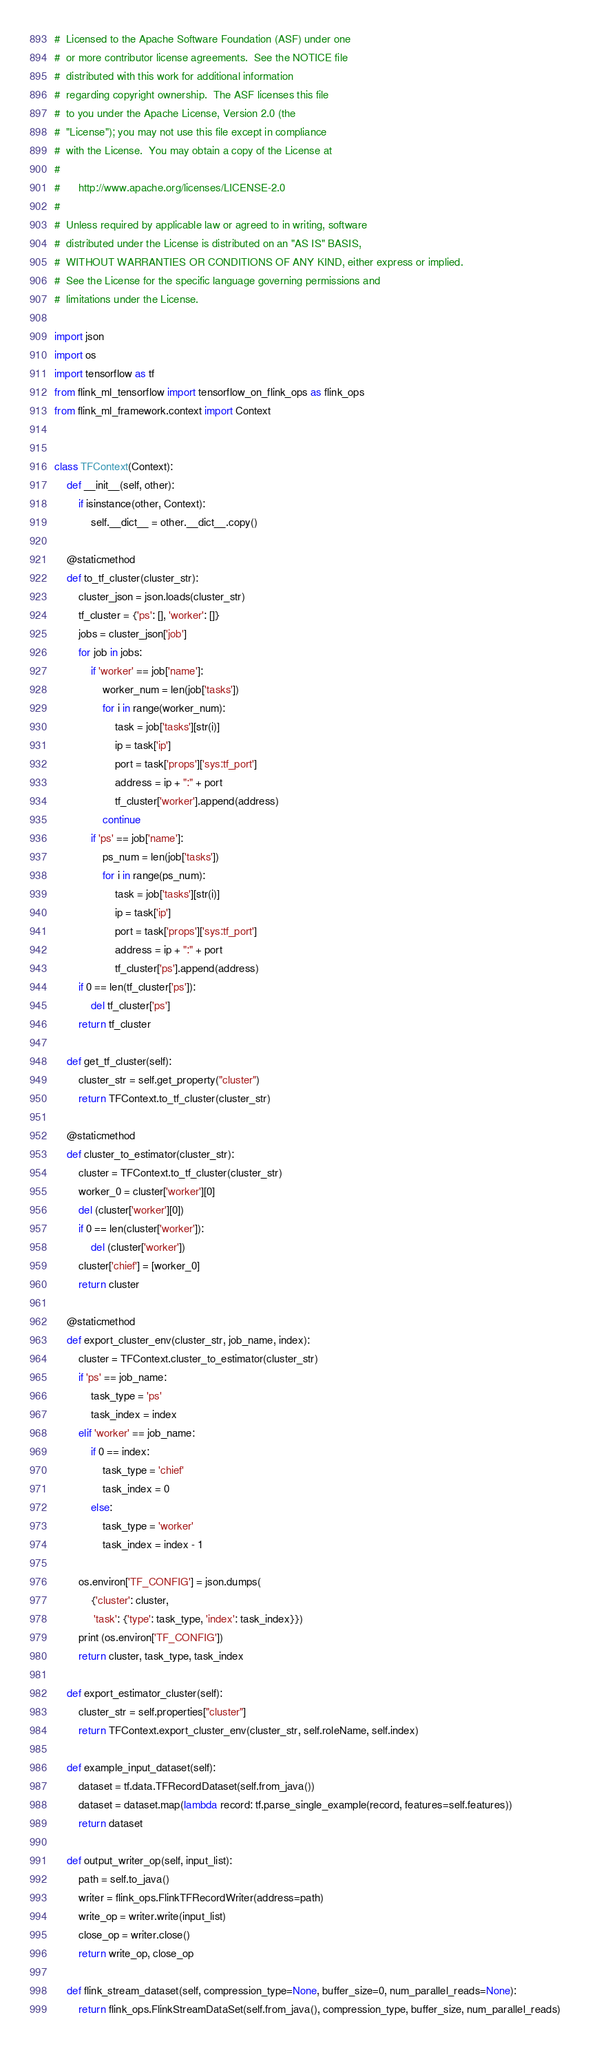<code> <loc_0><loc_0><loc_500><loc_500><_Python_>#  Licensed to the Apache Software Foundation (ASF) under one
#  or more contributor license agreements.  See the NOTICE file
#  distributed with this work for additional information
#  regarding copyright ownership.  The ASF licenses this file
#  to you under the Apache License, Version 2.0 (the
#  "License"); you may not use this file except in compliance
#  with the License.  You may obtain a copy of the License at
#
#      http://www.apache.org/licenses/LICENSE-2.0
#
#  Unless required by applicable law or agreed to in writing, software
#  distributed under the License is distributed on an "AS IS" BASIS,
#  WITHOUT WARRANTIES OR CONDITIONS OF ANY KIND, either express or implied.
#  See the License for the specific language governing permissions and
#  limitations under the License.

import json
import os
import tensorflow as tf
from flink_ml_tensorflow import tensorflow_on_flink_ops as flink_ops
from flink_ml_framework.context import Context


class TFContext(Context):
    def __init__(self, other):
        if isinstance(other, Context):
            self.__dict__ = other.__dict__.copy()

    @staticmethod
    def to_tf_cluster(cluster_str):
        cluster_json = json.loads(cluster_str)
        tf_cluster = {'ps': [], 'worker': []}
        jobs = cluster_json['job']
        for job in jobs:
            if 'worker' == job['name']:
                worker_num = len(job['tasks'])
                for i in range(worker_num):
                    task = job['tasks'][str(i)]
                    ip = task['ip']
                    port = task['props']['sys:tf_port']
                    address = ip + ":" + port
                    tf_cluster['worker'].append(address)
                continue
            if 'ps' == job['name']:
                ps_num = len(job['tasks'])
                for i in range(ps_num):
                    task = job['tasks'][str(i)]
                    ip = task['ip']
                    port = task['props']['sys:tf_port']
                    address = ip + ":" + port
                    tf_cluster['ps'].append(address)
        if 0 == len(tf_cluster['ps']):
            del tf_cluster['ps']
        return tf_cluster

    def get_tf_cluster(self):
        cluster_str = self.get_property("cluster")
        return TFContext.to_tf_cluster(cluster_str)

    @staticmethod
    def cluster_to_estimator(cluster_str):
        cluster = TFContext.to_tf_cluster(cluster_str)
        worker_0 = cluster['worker'][0]
        del (cluster['worker'][0])
        if 0 == len(cluster['worker']):
            del (cluster['worker'])
        cluster['chief'] = [worker_0]
        return cluster

    @staticmethod
    def export_cluster_env(cluster_str, job_name, index):
        cluster = TFContext.cluster_to_estimator(cluster_str)
        if 'ps' == job_name:
            task_type = 'ps'
            task_index = index
        elif 'worker' == job_name:
            if 0 == index:
                task_type = 'chief'
                task_index = 0
            else:
                task_type = 'worker'
                task_index = index - 1

        os.environ['TF_CONFIG'] = json.dumps(
            {'cluster': cluster,
             'task': {'type': task_type, 'index': task_index}})
        print (os.environ['TF_CONFIG'])
        return cluster, task_type, task_index

    def export_estimator_cluster(self):
        cluster_str = self.properties["cluster"]
        return TFContext.export_cluster_env(cluster_str, self.roleName, self.index)

    def example_input_dataset(self):
        dataset = tf.data.TFRecordDataset(self.from_java())
        dataset = dataset.map(lambda record: tf.parse_single_example(record, features=self.features))
        return dataset

    def output_writer_op(self, input_list):
        path = self.to_java()
        writer = flink_ops.FlinkTFRecordWriter(address=path)
        write_op = writer.write(input_list)
        close_op = writer.close()
        return write_op, close_op

    def flink_stream_dataset(self, compression_type=None, buffer_size=0, num_parallel_reads=None):
        return flink_ops.FlinkStreamDataSet(self.from_java(), compression_type, buffer_size, num_parallel_reads)
</code> 